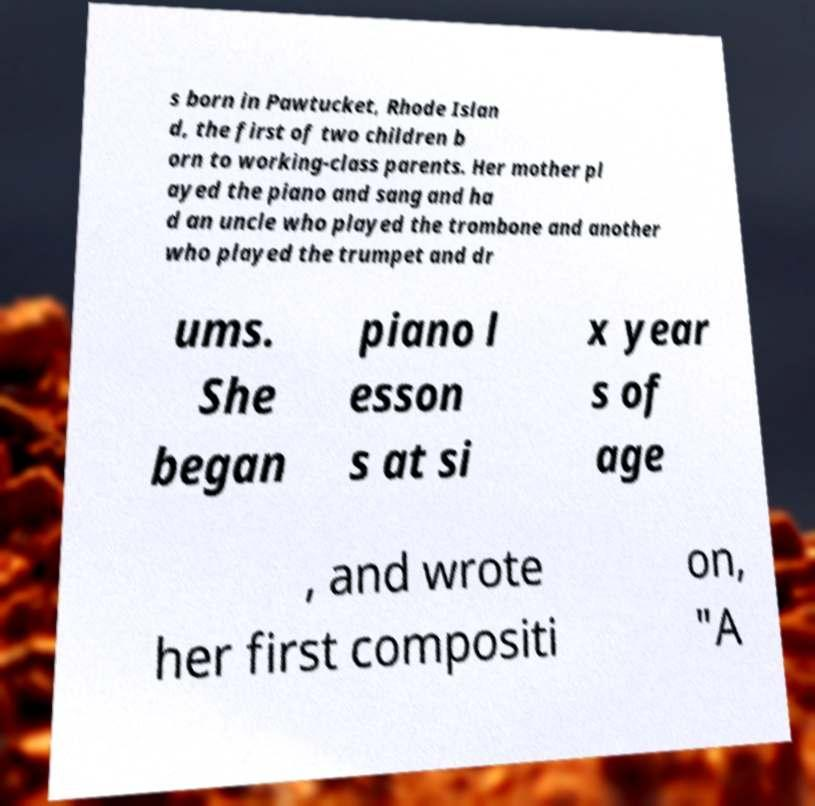Can you read and provide the text displayed in the image?This photo seems to have some interesting text. Can you extract and type it out for me? s born in Pawtucket, Rhode Islan d, the first of two children b orn to working-class parents. Her mother pl ayed the piano and sang and ha d an uncle who played the trombone and another who played the trumpet and dr ums. She began piano l esson s at si x year s of age , and wrote her first compositi on, "A 